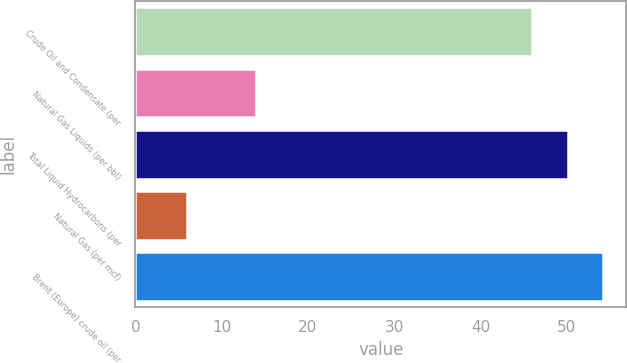<chart> <loc_0><loc_0><loc_500><loc_500><bar_chart><fcel>Crude Oil and Condensate (per<fcel>Natural Gas Liquids (per bbl)<fcel>Total Liquid Hydrocarbons (per<fcel>Natural Gas (per mcf)<fcel>Brent (Europe) crude oil (per<nl><fcel>46<fcel>14<fcel>50.1<fcel>6<fcel>54.2<nl></chart> 